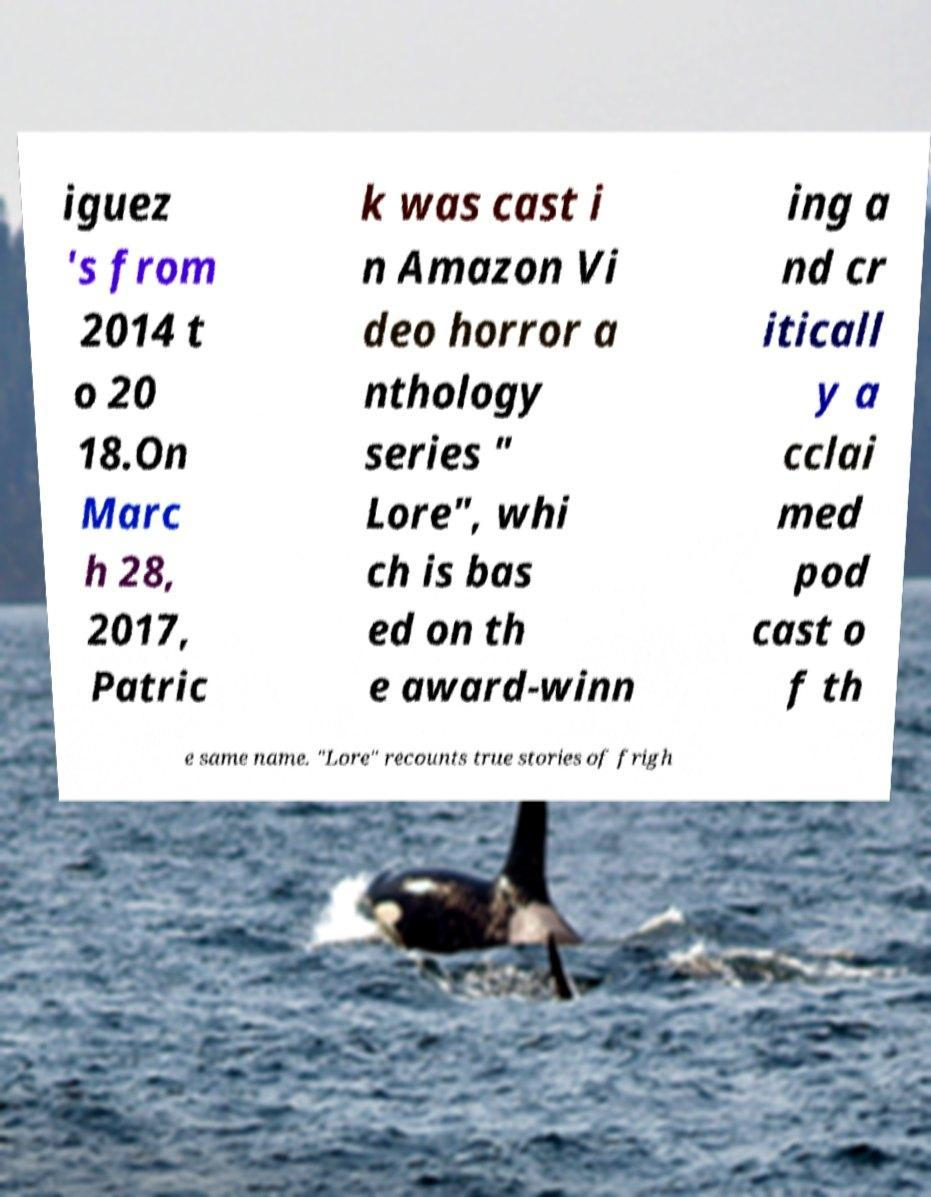Please read and relay the text visible in this image. What does it say? iguez 's from 2014 t o 20 18.On Marc h 28, 2017, Patric k was cast i n Amazon Vi deo horror a nthology series " Lore", whi ch is bas ed on th e award-winn ing a nd cr iticall y a cclai med pod cast o f th e same name. "Lore" recounts true stories of frigh 